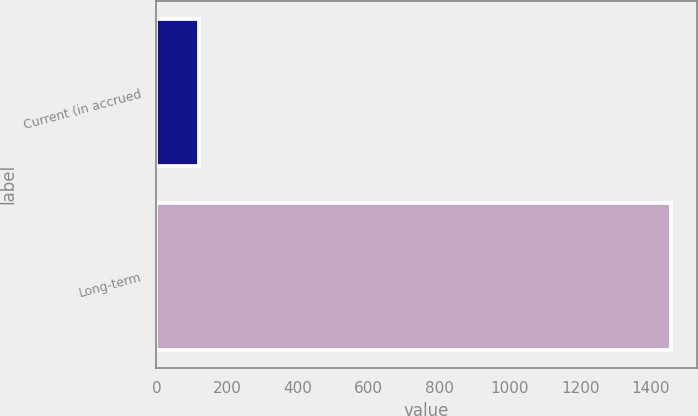Convert chart. <chart><loc_0><loc_0><loc_500><loc_500><bar_chart><fcel>Current (in accrued<fcel>Long-term<nl><fcel>119<fcel>1457<nl></chart> 